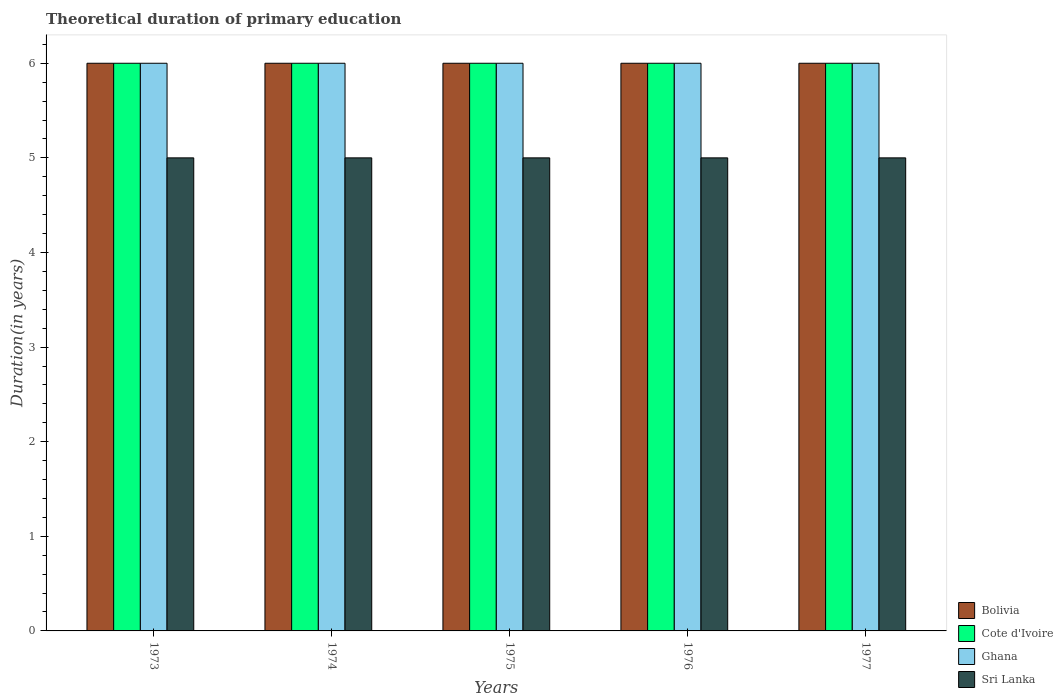How many different coloured bars are there?
Offer a very short reply. 4. Are the number of bars on each tick of the X-axis equal?
Your response must be concise. Yes. What is the label of the 4th group of bars from the left?
Make the answer very short. 1976. In how many cases, is the number of bars for a given year not equal to the number of legend labels?
Your answer should be very brief. 0. Across all years, what is the minimum total theoretical duration of primary education in Sri Lanka?
Provide a succinct answer. 5. In which year was the total theoretical duration of primary education in Ghana maximum?
Your answer should be compact. 1973. What is the total total theoretical duration of primary education in Ghana in the graph?
Make the answer very short. 30. In the year 1974, what is the difference between the total theoretical duration of primary education in Cote d'Ivoire and total theoretical duration of primary education in Bolivia?
Your response must be concise. 0. Is the total theoretical duration of primary education in Ghana in 1973 less than that in 1977?
Give a very brief answer. No. What is the difference between the highest and the second highest total theoretical duration of primary education in Ghana?
Offer a terse response. 0. What is the difference between the highest and the lowest total theoretical duration of primary education in Cote d'Ivoire?
Give a very brief answer. 0. Is the sum of the total theoretical duration of primary education in Sri Lanka in 1973 and 1977 greater than the maximum total theoretical duration of primary education in Cote d'Ivoire across all years?
Give a very brief answer. Yes. Is it the case that in every year, the sum of the total theoretical duration of primary education in Cote d'Ivoire and total theoretical duration of primary education in Bolivia is greater than the sum of total theoretical duration of primary education in Ghana and total theoretical duration of primary education in Sri Lanka?
Ensure brevity in your answer.  No. What does the 3rd bar from the left in 1977 represents?
Your answer should be very brief. Ghana. What does the 1st bar from the right in 1976 represents?
Your answer should be compact. Sri Lanka. How many bars are there?
Your answer should be very brief. 20. How many years are there in the graph?
Make the answer very short. 5. Are the values on the major ticks of Y-axis written in scientific E-notation?
Provide a short and direct response. No. Does the graph contain grids?
Offer a very short reply. No. How many legend labels are there?
Your answer should be compact. 4. What is the title of the graph?
Make the answer very short. Theoretical duration of primary education. Does "Sudan" appear as one of the legend labels in the graph?
Keep it short and to the point. No. What is the label or title of the X-axis?
Your answer should be compact. Years. What is the label or title of the Y-axis?
Your answer should be very brief. Duration(in years). What is the Duration(in years) in Bolivia in 1973?
Ensure brevity in your answer.  6. What is the Duration(in years) in Ghana in 1973?
Offer a very short reply. 6. What is the Duration(in years) of Bolivia in 1974?
Provide a short and direct response. 6. What is the Duration(in years) in Cote d'Ivoire in 1974?
Your response must be concise. 6. What is the Duration(in years) in Ghana in 1974?
Provide a short and direct response. 6. What is the Duration(in years) in Sri Lanka in 1974?
Make the answer very short. 5. What is the Duration(in years) in Bolivia in 1975?
Give a very brief answer. 6. What is the Duration(in years) in Cote d'Ivoire in 1975?
Offer a very short reply. 6. What is the Duration(in years) in Bolivia in 1976?
Your answer should be very brief. 6. What is the Duration(in years) of Cote d'Ivoire in 1976?
Your response must be concise. 6. What is the Duration(in years) of Bolivia in 1977?
Your response must be concise. 6. What is the Duration(in years) of Cote d'Ivoire in 1977?
Your response must be concise. 6. Across all years, what is the maximum Duration(in years) in Ghana?
Offer a terse response. 6. Across all years, what is the minimum Duration(in years) of Bolivia?
Your response must be concise. 6. Across all years, what is the minimum Duration(in years) in Ghana?
Make the answer very short. 6. Across all years, what is the minimum Duration(in years) of Sri Lanka?
Make the answer very short. 5. What is the total Duration(in years) in Cote d'Ivoire in the graph?
Give a very brief answer. 30. What is the total Duration(in years) of Ghana in the graph?
Offer a very short reply. 30. What is the difference between the Duration(in years) in Bolivia in 1973 and that in 1974?
Offer a terse response. 0. What is the difference between the Duration(in years) of Cote d'Ivoire in 1973 and that in 1974?
Keep it short and to the point. 0. What is the difference between the Duration(in years) in Ghana in 1973 and that in 1974?
Ensure brevity in your answer.  0. What is the difference between the Duration(in years) of Bolivia in 1973 and that in 1975?
Give a very brief answer. 0. What is the difference between the Duration(in years) in Cote d'Ivoire in 1973 and that in 1975?
Your response must be concise. 0. What is the difference between the Duration(in years) in Sri Lanka in 1973 and that in 1975?
Keep it short and to the point. 0. What is the difference between the Duration(in years) in Cote d'Ivoire in 1973 and that in 1976?
Offer a very short reply. 0. What is the difference between the Duration(in years) in Sri Lanka in 1973 and that in 1976?
Offer a terse response. 0. What is the difference between the Duration(in years) in Bolivia in 1973 and that in 1977?
Your response must be concise. 0. What is the difference between the Duration(in years) of Ghana in 1973 and that in 1977?
Offer a terse response. 0. What is the difference between the Duration(in years) of Ghana in 1974 and that in 1975?
Offer a very short reply. 0. What is the difference between the Duration(in years) in Cote d'Ivoire in 1974 and that in 1976?
Provide a short and direct response. 0. What is the difference between the Duration(in years) in Sri Lanka in 1974 and that in 1976?
Your answer should be compact. 0. What is the difference between the Duration(in years) in Cote d'Ivoire in 1974 and that in 1977?
Offer a very short reply. 0. What is the difference between the Duration(in years) of Ghana in 1974 and that in 1977?
Your answer should be very brief. 0. What is the difference between the Duration(in years) in Bolivia in 1975 and that in 1976?
Offer a terse response. 0. What is the difference between the Duration(in years) of Cote d'Ivoire in 1975 and that in 1976?
Your answer should be compact. 0. What is the difference between the Duration(in years) of Ghana in 1975 and that in 1976?
Provide a succinct answer. 0. What is the difference between the Duration(in years) of Cote d'Ivoire in 1975 and that in 1977?
Give a very brief answer. 0. What is the difference between the Duration(in years) in Ghana in 1975 and that in 1977?
Your answer should be very brief. 0. What is the difference between the Duration(in years) in Bolivia in 1976 and that in 1977?
Give a very brief answer. 0. What is the difference between the Duration(in years) in Bolivia in 1973 and the Duration(in years) in Cote d'Ivoire in 1974?
Offer a terse response. 0. What is the difference between the Duration(in years) of Cote d'Ivoire in 1973 and the Duration(in years) of Ghana in 1974?
Provide a short and direct response. 0. What is the difference between the Duration(in years) in Ghana in 1973 and the Duration(in years) in Sri Lanka in 1974?
Provide a short and direct response. 1. What is the difference between the Duration(in years) in Bolivia in 1973 and the Duration(in years) in Cote d'Ivoire in 1975?
Your response must be concise. 0. What is the difference between the Duration(in years) of Bolivia in 1973 and the Duration(in years) of Ghana in 1975?
Provide a short and direct response. 0. What is the difference between the Duration(in years) of Cote d'Ivoire in 1973 and the Duration(in years) of Ghana in 1975?
Offer a very short reply. 0. What is the difference between the Duration(in years) in Cote d'Ivoire in 1973 and the Duration(in years) in Sri Lanka in 1975?
Your answer should be compact. 1. What is the difference between the Duration(in years) of Bolivia in 1973 and the Duration(in years) of Cote d'Ivoire in 1976?
Your answer should be very brief. 0. What is the difference between the Duration(in years) of Bolivia in 1973 and the Duration(in years) of Cote d'Ivoire in 1977?
Ensure brevity in your answer.  0. What is the difference between the Duration(in years) of Bolivia in 1974 and the Duration(in years) of Ghana in 1975?
Your answer should be very brief. 0. What is the difference between the Duration(in years) in Bolivia in 1974 and the Duration(in years) in Sri Lanka in 1975?
Provide a short and direct response. 1. What is the difference between the Duration(in years) of Cote d'Ivoire in 1974 and the Duration(in years) of Ghana in 1975?
Offer a very short reply. 0. What is the difference between the Duration(in years) of Cote d'Ivoire in 1974 and the Duration(in years) of Sri Lanka in 1975?
Make the answer very short. 1. What is the difference between the Duration(in years) of Bolivia in 1974 and the Duration(in years) of Sri Lanka in 1976?
Provide a short and direct response. 1. What is the difference between the Duration(in years) in Cote d'Ivoire in 1974 and the Duration(in years) in Ghana in 1976?
Ensure brevity in your answer.  0. What is the difference between the Duration(in years) of Bolivia in 1974 and the Duration(in years) of Sri Lanka in 1977?
Provide a short and direct response. 1. What is the difference between the Duration(in years) of Bolivia in 1975 and the Duration(in years) of Cote d'Ivoire in 1976?
Offer a terse response. 0. What is the difference between the Duration(in years) in Bolivia in 1975 and the Duration(in years) in Ghana in 1976?
Ensure brevity in your answer.  0. What is the difference between the Duration(in years) of Bolivia in 1975 and the Duration(in years) of Sri Lanka in 1976?
Your answer should be compact. 1. What is the difference between the Duration(in years) in Cote d'Ivoire in 1975 and the Duration(in years) in Ghana in 1976?
Offer a terse response. 0. What is the difference between the Duration(in years) in Bolivia in 1975 and the Duration(in years) in Cote d'Ivoire in 1977?
Your answer should be very brief. 0. What is the difference between the Duration(in years) of Bolivia in 1975 and the Duration(in years) of Ghana in 1977?
Keep it short and to the point. 0. What is the difference between the Duration(in years) in Bolivia in 1975 and the Duration(in years) in Sri Lanka in 1977?
Provide a succinct answer. 1. What is the difference between the Duration(in years) of Cote d'Ivoire in 1975 and the Duration(in years) of Ghana in 1977?
Provide a short and direct response. 0. What is the difference between the Duration(in years) of Cote d'Ivoire in 1975 and the Duration(in years) of Sri Lanka in 1977?
Offer a very short reply. 1. What is the difference between the Duration(in years) in Ghana in 1975 and the Duration(in years) in Sri Lanka in 1977?
Make the answer very short. 1. What is the difference between the Duration(in years) of Cote d'Ivoire in 1976 and the Duration(in years) of Ghana in 1977?
Provide a short and direct response. 0. What is the difference between the Duration(in years) in Cote d'Ivoire in 1976 and the Duration(in years) in Sri Lanka in 1977?
Offer a terse response. 1. What is the average Duration(in years) in Ghana per year?
Keep it short and to the point. 6. What is the average Duration(in years) in Sri Lanka per year?
Provide a short and direct response. 5. In the year 1973, what is the difference between the Duration(in years) of Bolivia and Duration(in years) of Sri Lanka?
Your response must be concise. 1. In the year 1973, what is the difference between the Duration(in years) in Cote d'Ivoire and Duration(in years) in Ghana?
Make the answer very short. 0. In the year 1974, what is the difference between the Duration(in years) in Bolivia and Duration(in years) in Ghana?
Give a very brief answer. 0. In the year 1974, what is the difference between the Duration(in years) in Cote d'Ivoire and Duration(in years) in Sri Lanka?
Provide a short and direct response. 1. In the year 1975, what is the difference between the Duration(in years) of Bolivia and Duration(in years) of Ghana?
Keep it short and to the point. 0. In the year 1975, what is the difference between the Duration(in years) of Cote d'Ivoire and Duration(in years) of Sri Lanka?
Your answer should be very brief. 1. In the year 1975, what is the difference between the Duration(in years) of Ghana and Duration(in years) of Sri Lanka?
Offer a very short reply. 1. In the year 1976, what is the difference between the Duration(in years) of Bolivia and Duration(in years) of Cote d'Ivoire?
Offer a terse response. 0. In the year 1976, what is the difference between the Duration(in years) in Bolivia and Duration(in years) in Sri Lanka?
Give a very brief answer. 1. In the year 1976, what is the difference between the Duration(in years) in Cote d'Ivoire and Duration(in years) in Ghana?
Provide a succinct answer. 0. In the year 1976, what is the difference between the Duration(in years) of Ghana and Duration(in years) of Sri Lanka?
Your answer should be very brief. 1. In the year 1977, what is the difference between the Duration(in years) of Bolivia and Duration(in years) of Cote d'Ivoire?
Your answer should be compact. 0. In the year 1977, what is the difference between the Duration(in years) in Bolivia and Duration(in years) in Ghana?
Ensure brevity in your answer.  0. In the year 1977, what is the difference between the Duration(in years) in Cote d'Ivoire and Duration(in years) in Ghana?
Offer a very short reply. 0. In the year 1977, what is the difference between the Duration(in years) of Ghana and Duration(in years) of Sri Lanka?
Offer a terse response. 1. What is the ratio of the Duration(in years) in Ghana in 1973 to that in 1974?
Your answer should be compact. 1. What is the ratio of the Duration(in years) of Ghana in 1973 to that in 1975?
Your answer should be very brief. 1. What is the ratio of the Duration(in years) of Sri Lanka in 1973 to that in 1975?
Your answer should be very brief. 1. What is the ratio of the Duration(in years) in Cote d'Ivoire in 1973 to that in 1976?
Your answer should be very brief. 1. What is the ratio of the Duration(in years) in Ghana in 1973 to that in 1976?
Ensure brevity in your answer.  1. What is the ratio of the Duration(in years) of Bolivia in 1973 to that in 1977?
Provide a short and direct response. 1. What is the ratio of the Duration(in years) in Cote d'Ivoire in 1973 to that in 1977?
Offer a terse response. 1. What is the ratio of the Duration(in years) of Sri Lanka in 1973 to that in 1977?
Your answer should be compact. 1. What is the ratio of the Duration(in years) of Bolivia in 1974 to that in 1975?
Ensure brevity in your answer.  1. What is the ratio of the Duration(in years) of Sri Lanka in 1974 to that in 1975?
Your answer should be very brief. 1. What is the ratio of the Duration(in years) in Ghana in 1974 to that in 1976?
Your response must be concise. 1. What is the ratio of the Duration(in years) of Sri Lanka in 1974 to that in 1976?
Your answer should be very brief. 1. What is the ratio of the Duration(in years) in Bolivia in 1974 to that in 1977?
Provide a short and direct response. 1. What is the ratio of the Duration(in years) in Ghana in 1974 to that in 1977?
Ensure brevity in your answer.  1. What is the ratio of the Duration(in years) in Sri Lanka in 1974 to that in 1977?
Make the answer very short. 1. What is the ratio of the Duration(in years) in Bolivia in 1975 to that in 1976?
Make the answer very short. 1. What is the ratio of the Duration(in years) in Cote d'Ivoire in 1975 to that in 1976?
Make the answer very short. 1. What is the ratio of the Duration(in years) of Ghana in 1976 to that in 1977?
Provide a succinct answer. 1. What is the difference between the highest and the second highest Duration(in years) in Sri Lanka?
Give a very brief answer. 0. What is the difference between the highest and the lowest Duration(in years) in Bolivia?
Offer a very short reply. 0. What is the difference between the highest and the lowest Duration(in years) in Cote d'Ivoire?
Give a very brief answer. 0. What is the difference between the highest and the lowest Duration(in years) in Ghana?
Make the answer very short. 0. 